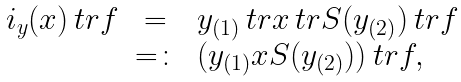<formula> <loc_0><loc_0><loc_500><loc_500>\begin{array} { r c l } \L i _ { y } ( x ) \ t r f & = \, & y _ { ( 1 ) } \ t r x \ t r S ( y _ { ( 2 ) } ) \ t r f \\ & = \colon & ( y _ { ( 1 ) } x S ( y _ { ( 2 ) } ) ) \ t r f , \end{array}</formula> 